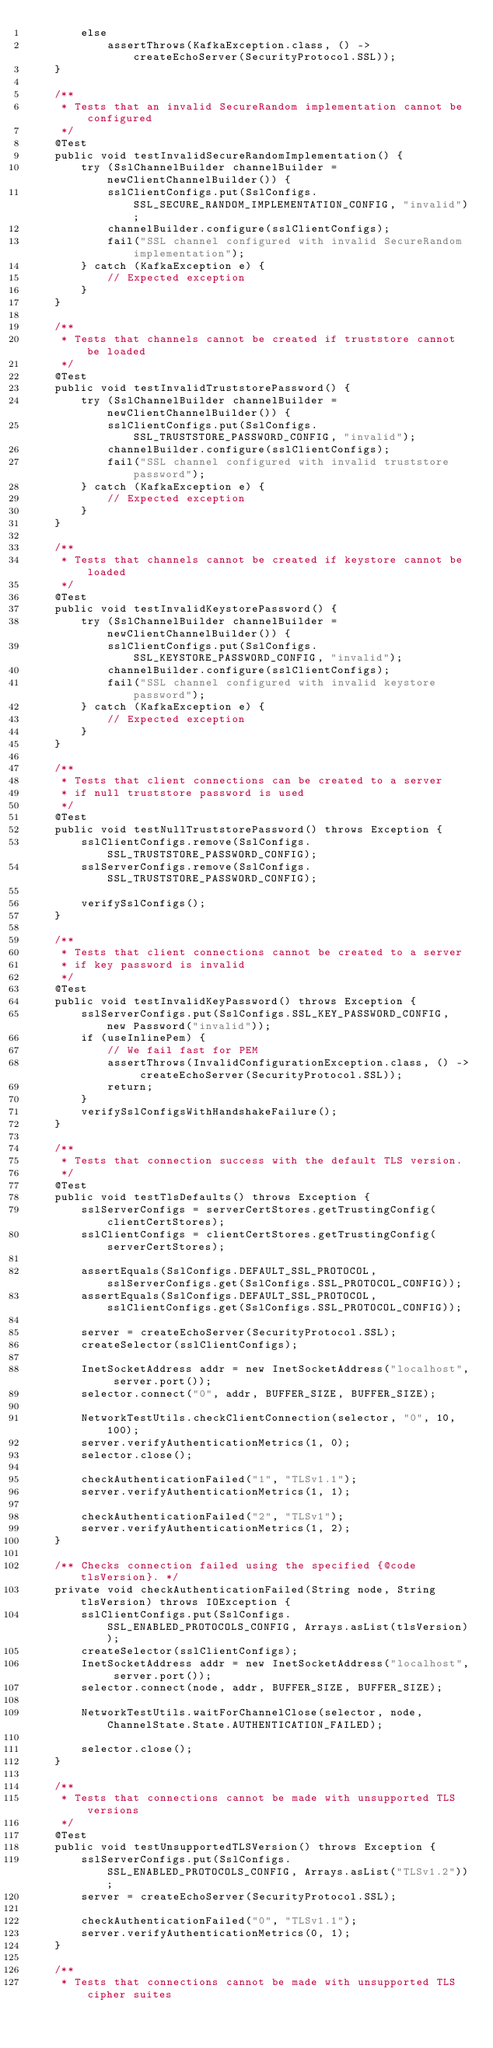Convert code to text. <code><loc_0><loc_0><loc_500><loc_500><_Java_>        else
            assertThrows(KafkaException.class, () -> createEchoServer(SecurityProtocol.SSL));
    }

    /**
     * Tests that an invalid SecureRandom implementation cannot be configured
     */
    @Test
    public void testInvalidSecureRandomImplementation() {
        try (SslChannelBuilder channelBuilder = newClientChannelBuilder()) {
            sslClientConfigs.put(SslConfigs.SSL_SECURE_RANDOM_IMPLEMENTATION_CONFIG, "invalid");
            channelBuilder.configure(sslClientConfigs);
            fail("SSL channel configured with invalid SecureRandom implementation");
        } catch (KafkaException e) {
            // Expected exception
        }
    }

    /**
     * Tests that channels cannot be created if truststore cannot be loaded
     */
    @Test
    public void testInvalidTruststorePassword() {
        try (SslChannelBuilder channelBuilder = newClientChannelBuilder()) {
            sslClientConfigs.put(SslConfigs.SSL_TRUSTSTORE_PASSWORD_CONFIG, "invalid");
            channelBuilder.configure(sslClientConfigs);
            fail("SSL channel configured with invalid truststore password");
        } catch (KafkaException e) {
            // Expected exception
        }
    }

    /**
     * Tests that channels cannot be created if keystore cannot be loaded
     */
    @Test
    public void testInvalidKeystorePassword() {
        try (SslChannelBuilder channelBuilder = newClientChannelBuilder()) {
            sslClientConfigs.put(SslConfigs.SSL_KEYSTORE_PASSWORD_CONFIG, "invalid");
            channelBuilder.configure(sslClientConfigs);
            fail("SSL channel configured with invalid keystore password");
        } catch (KafkaException e) {
            // Expected exception
        }
    }

    /**
     * Tests that client connections can be created to a server
     * if null truststore password is used
     */
    @Test
    public void testNullTruststorePassword() throws Exception {
        sslClientConfigs.remove(SslConfigs.SSL_TRUSTSTORE_PASSWORD_CONFIG);
        sslServerConfigs.remove(SslConfigs.SSL_TRUSTSTORE_PASSWORD_CONFIG);

        verifySslConfigs();
    }

    /**
     * Tests that client connections cannot be created to a server
     * if key password is invalid
     */
    @Test
    public void testInvalidKeyPassword() throws Exception {
        sslServerConfigs.put(SslConfigs.SSL_KEY_PASSWORD_CONFIG, new Password("invalid"));
        if (useInlinePem) {
            // We fail fast for PEM
            assertThrows(InvalidConfigurationException.class, () -> createEchoServer(SecurityProtocol.SSL));
            return;
        }
        verifySslConfigsWithHandshakeFailure();
    }

    /**
     * Tests that connection success with the default TLS version.
     */
    @Test
    public void testTlsDefaults() throws Exception {
        sslServerConfigs = serverCertStores.getTrustingConfig(clientCertStores);
        sslClientConfigs = clientCertStores.getTrustingConfig(serverCertStores);

        assertEquals(SslConfigs.DEFAULT_SSL_PROTOCOL, sslServerConfigs.get(SslConfigs.SSL_PROTOCOL_CONFIG));
        assertEquals(SslConfigs.DEFAULT_SSL_PROTOCOL, sslClientConfigs.get(SslConfigs.SSL_PROTOCOL_CONFIG));

        server = createEchoServer(SecurityProtocol.SSL);
        createSelector(sslClientConfigs);

        InetSocketAddress addr = new InetSocketAddress("localhost", server.port());
        selector.connect("0", addr, BUFFER_SIZE, BUFFER_SIZE);

        NetworkTestUtils.checkClientConnection(selector, "0", 10, 100);
        server.verifyAuthenticationMetrics(1, 0);
        selector.close();

        checkAuthenticationFailed("1", "TLSv1.1");
        server.verifyAuthenticationMetrics(1, 1);

        checkAuthenticationFailed("2", "TLSv1");
        server.verifyAuthenticationMetrics(1, 2);
    }

    /** Checks connection failed using the specified {@code tlsVersion}. */
    private void checkAuthenticationFailed(String node, String tlsVersion) throws IOException {
        sslClientConfigs.put(SslConfigs.SSL_ENABLED_PROTOCOLS_CONFIG, Arrays.asList(tlsVersion));
        createSelector(sslClientConfigs);
        InetSocketAddress addr = new InetSocketAddress("localhost", server.port());
        selector.connect(node, addr, BUFFER_SIZE, BUFFER_SIZE);

        NetworkTestUtils.waitForChannelClose(selector, node, ChannelState.State.AUTHENTICATION_FAILED);

        selector.close();
    }

    /**
     * Tests that connections cannot be made with unsupported TLS versions
     */
    @Test
    public void testUnsupportedTLSVersion() throws Exception {
        sslServerConfigs.put(SslConfigs.SSL_ENABLED_PROTOCOLS_CONFIG, Arrays.asList("TLSv1.2"));
        server = createEchoServer(SecurityProtocol.SSL);

        checkAuthenticationFailed("0", "TLSv1.1");
        server.verifyAuthenticationMetrics(0, 1);
    }

    /**
     * Tests that connections cannot be made with unsupported TLS cipher suites</code> 